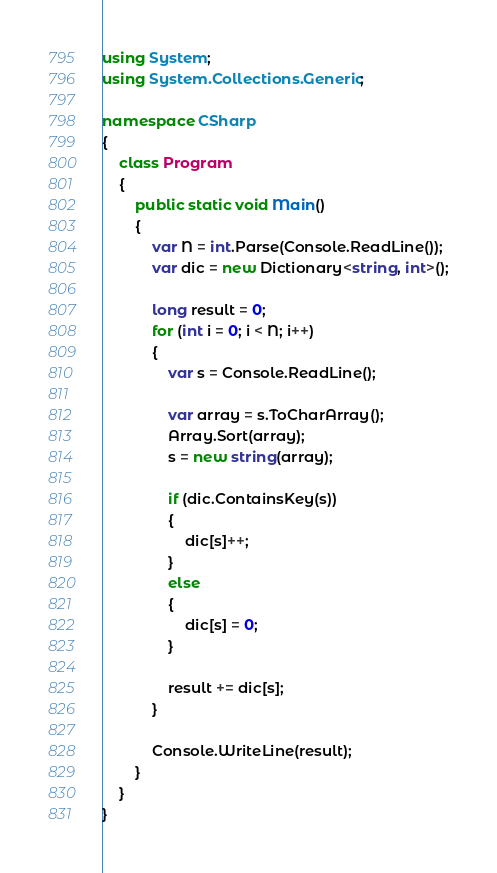Convert code to text. <code><loc_0><loc_0><loc_500><loc_500><_C#_>using System;
using System.Collections.Generic;

namespace CSharp
{
    class Program
    {
        public static void Main()
        {
            var N = int.Parse(Console.ReadLine());
            var dic = new Dictionary<string, int>();

            long result = 0;
            for (int i = 0; i < N; i++)
            {
                var s = Console.ReadLine();

                var array = s.ToCharArray();
                Array.Sort(array);
                s = new string(array);

                if (dic.ContainsKey(s))
                {
                    dic[s]++;
                }
                else
                {
                    dic[s] = 0;
                }

                result += dic[s];
            }

            Console.WriteLine(result);
        }
    }
}
</code> 